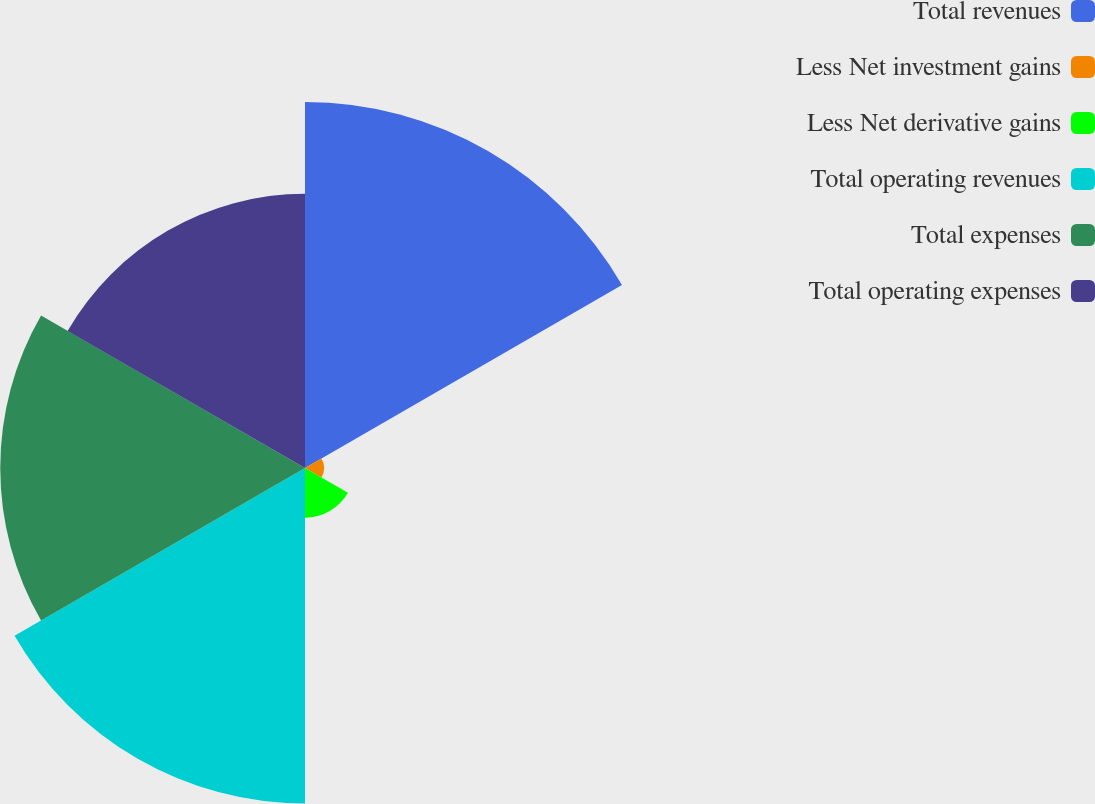Convert chart. <chart><loc_0><loc_0><loc_500><loc_500><pie_chart><fcel>Total revenues<fcel>Less Net investment gains<fcel>Less Net derivative gains<fcel>Total operating revenues<fcel>Total expenses<fcel>Total operating expenses<nl><fcel>27.13%<fcel>1.41%<fcel>3.68%<fcel>24.86%<fcel>22.59%<fcel>20.32%<nl></chart> 